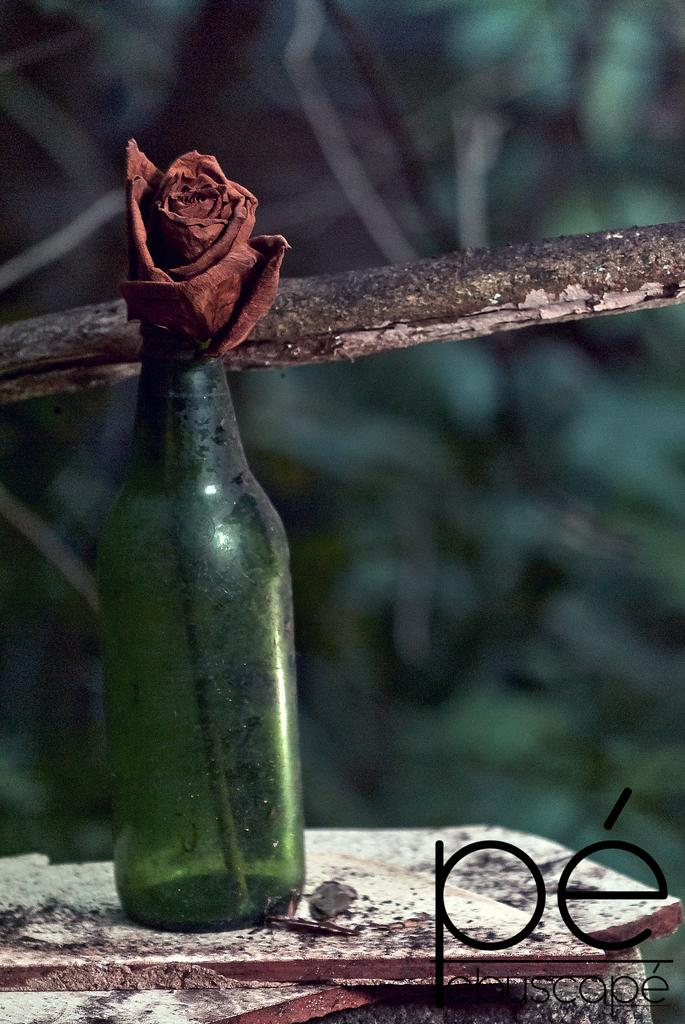What object is present in the image that contains a flower? There is a bottle in the image that has a flower in it. What color is the bottle? The bottle is green. What letters can be seen on the image? There are letters "P" and "D" on the image. What is in the middle of the image? There is a stick in the middle of the image. How many birds are sitting on the bells in the image? There are no birds or bells present in the image. What type of desk is visible in the image? There is no desk visible in the image. 